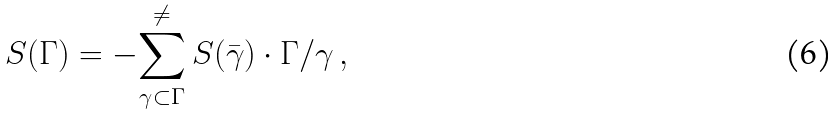Convert formula to latex. <formula><loc_0><loc_0><loc_500><loc_500>S ( \Gamma ) = - { \sum _ { \gamma \subset \Gamma } ^ { \neq } } \, S ( \bar { \gamma } ) \cdot \Gamma / \gamma \, ,</formula> 